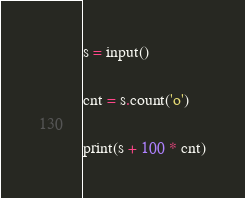Convert code to text. <code><loc_0><loc_0><loc_500><loc_500><_Python_>s = input()

cnt = s.count('o')

print(s + 100 * cnt)</code> 